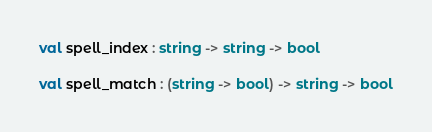<code> <loc_0><loc_0><loc_500><loc_500><_OCaml_>
val spell_index : string -> string -> bool

val spell_match : (string -> bool) -> string -> bool
</code> 